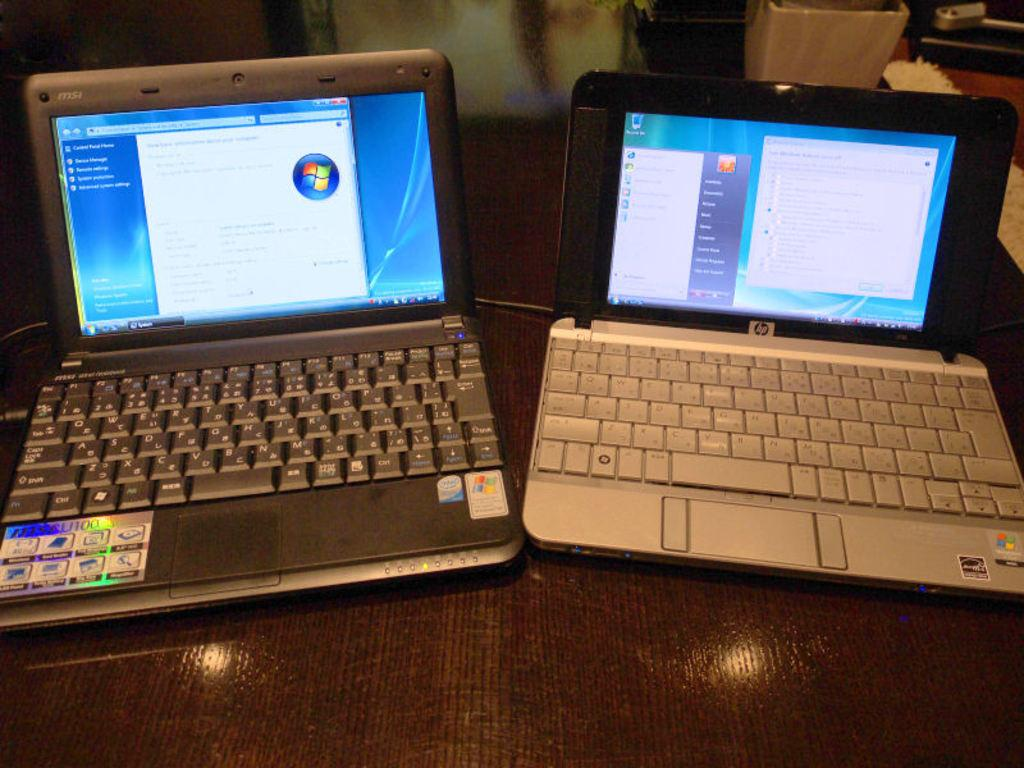What electronic devices can be seen in the image? There are laptops in the image. Where are the laptops located? The laptops are placed on a table. What type of eggs can be seen rolling on the table in the image? There are no eggs present in the image; it only features laptops on a table. 